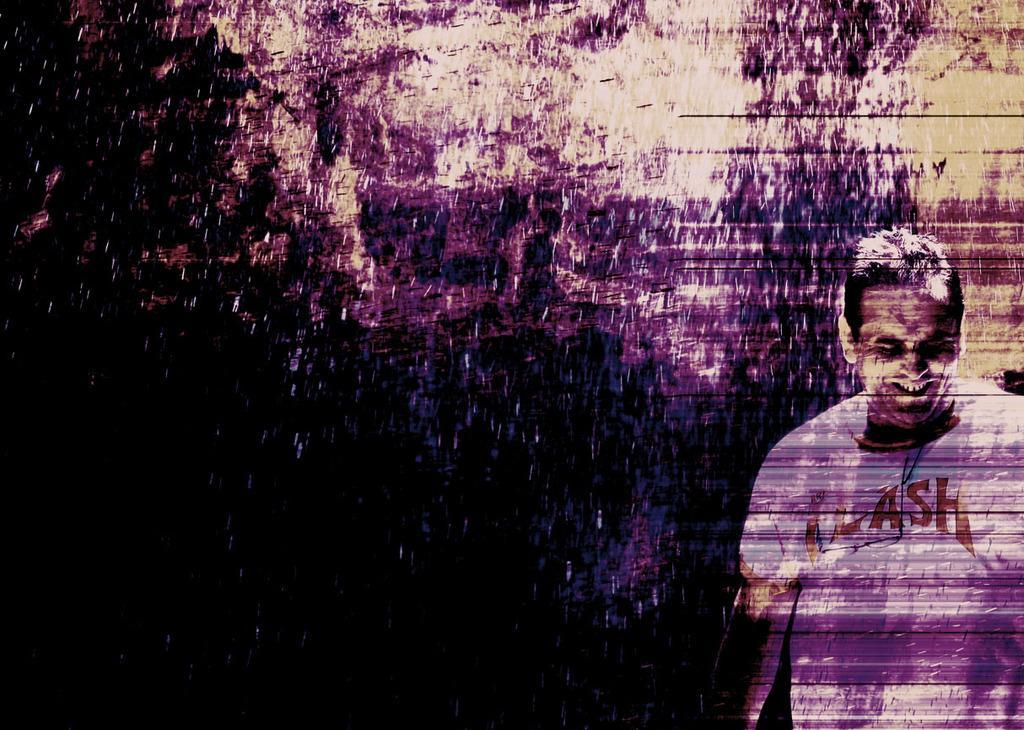How would you summarize this image in a sentence or two? In this image we can see a man is standing, and smiling, he is wearing the white t-shirt, the background is dark. 